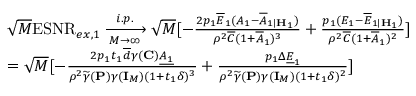<formula> <loc_0><loc_0><loc_500><loc_500>\begin{array} { r l } & { \sqrt { M } E S N R _ { e x , 1 } \xrightarrow [ M \rightarrow \infty ] { i . p . } \sqrt { M } [ - \frac { 2 p _ { 1 } \overline { E } _ { 1 } ( A _ { 1 } - \overline { A } _ { 1 | { H } _ { 1 } } ) } { \rho ^ { 2 } \overline { C } ( 1 + \overline { A } _ { 1 } ) ^ { 3 } } + \frac { p _ { 1 } ( E _ { 1 } - \overline { E } _ { 1 | { H } _ { 1 } } ) } { \rho ^ { 2 } \overline { C } ( 1 + \overline { A } _ { 1 } ) ^ { 2 } } ] } \\ & { = \sqrt { M } [ - \frac { 2 p _ { 1 } t _ { 1 } \overline { d } \gamma ( { C } ) \underline { { A _ { 1 } } } } { \rho ^ { 2 } \widetilde { \gamma } ( { P } ) \gamma ( { I } _ { M } ) ( 1 + t _ { 1 } \delta ) ^ { 3 } } + \frac { p _ { 1 } \Delta \underline { E } _ { 1 } } { \rho ^ { 2 } \widetilde { \gamma } ( { P } ) \gamma ( { I } _ { M } ) ( 1 + t _ { 1 } \delta ) ^ { 2 } } ] } \end{array}</formula> 